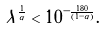Convert formula to latex. <formula><loc_0><loc_0><loc_500><loc_500>\tilde { \lambda } ^ { \frac { 1 } { \alpha } } < 1 0 ^ { - \frac { 1 8 0 } { \left ( 1 - \alpha \right ) } } .</formula> 